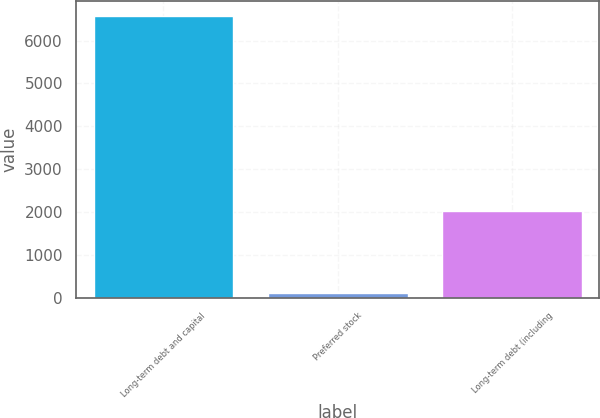Convert chart to OTSL. <chart><loc_0><loc_0><loc_500><loc_500><bar_chart><fcel>Long-term debt and capital<fcel>Preferred stock<fcel>Long-term debt (including<nl><fcel>6584<fcel>118<fcel>2028<nl></chart> 